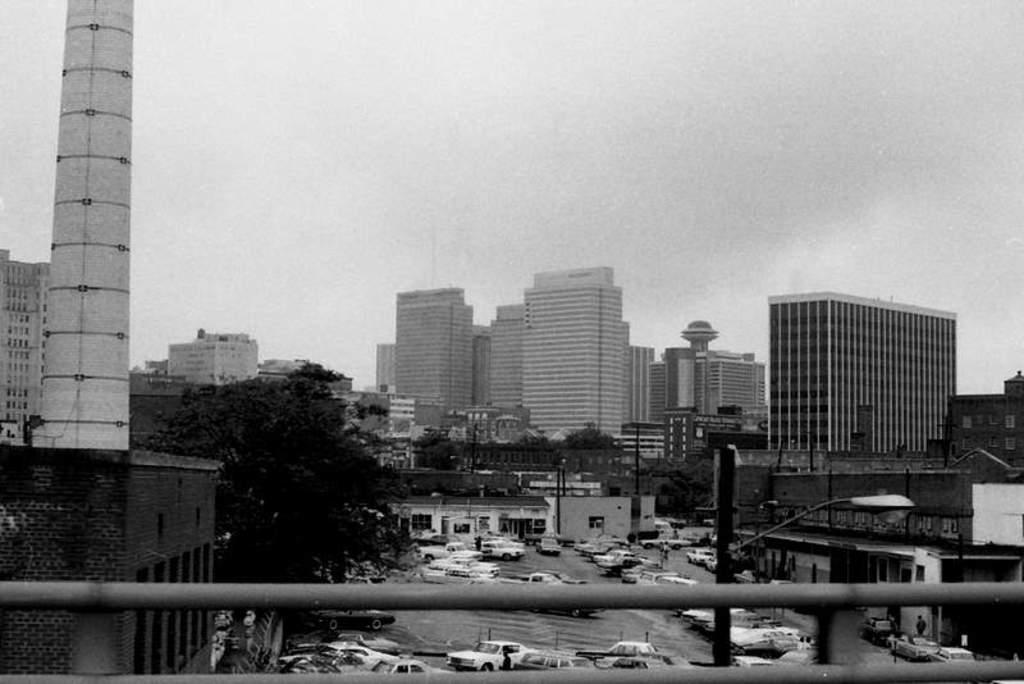How would you summarize this image in a sentence or two? In this image there are iron rods, vehicles on the road, poles, lights, buildings, trees,sky. 